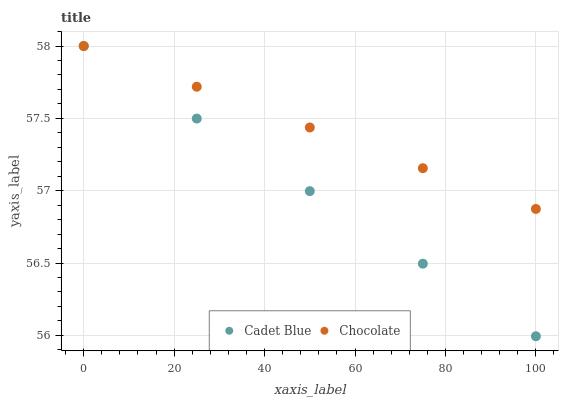Does Cadet Blue have the minimum area under the curve?
Answer yes or no. Yes. Does Chocolate have the maximum area under the curve?
Answer yes or no. Yes. Does Chocolate have the minimum area under the curve?
Answer yes or no. No. Is Chocolate the smoothest?
Answer yes or no. Yes. Is Cadet Blue the roughest?
Answer yes or no. Yes. Is Chocolate the roughest?
Answer yes or no. No. Does Cadet Blue have the lowest value?
Answer yes or no. Yes. Does Chocolate have the lowest value?
Answer yes or no. No. Does Chocolate have the highest value?
Answer yes or no. Yes. Does Cadet Blue intersect Chocolate?
Answer yes or no. Yes. Is Cadet Blue less than Chocolate?
Answer yes or no. No. Is Cadet Blue greater than Chocolate?
Answer yes or no. No. 